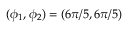Convert formula to latex. <formula><loc_0><loc_0><loc_500><loc_500>( \phi _ { 1 } , \phi _ { 2 } ) = ( 6 \pi / 5 , 6 \pi / 5 )</formula> 